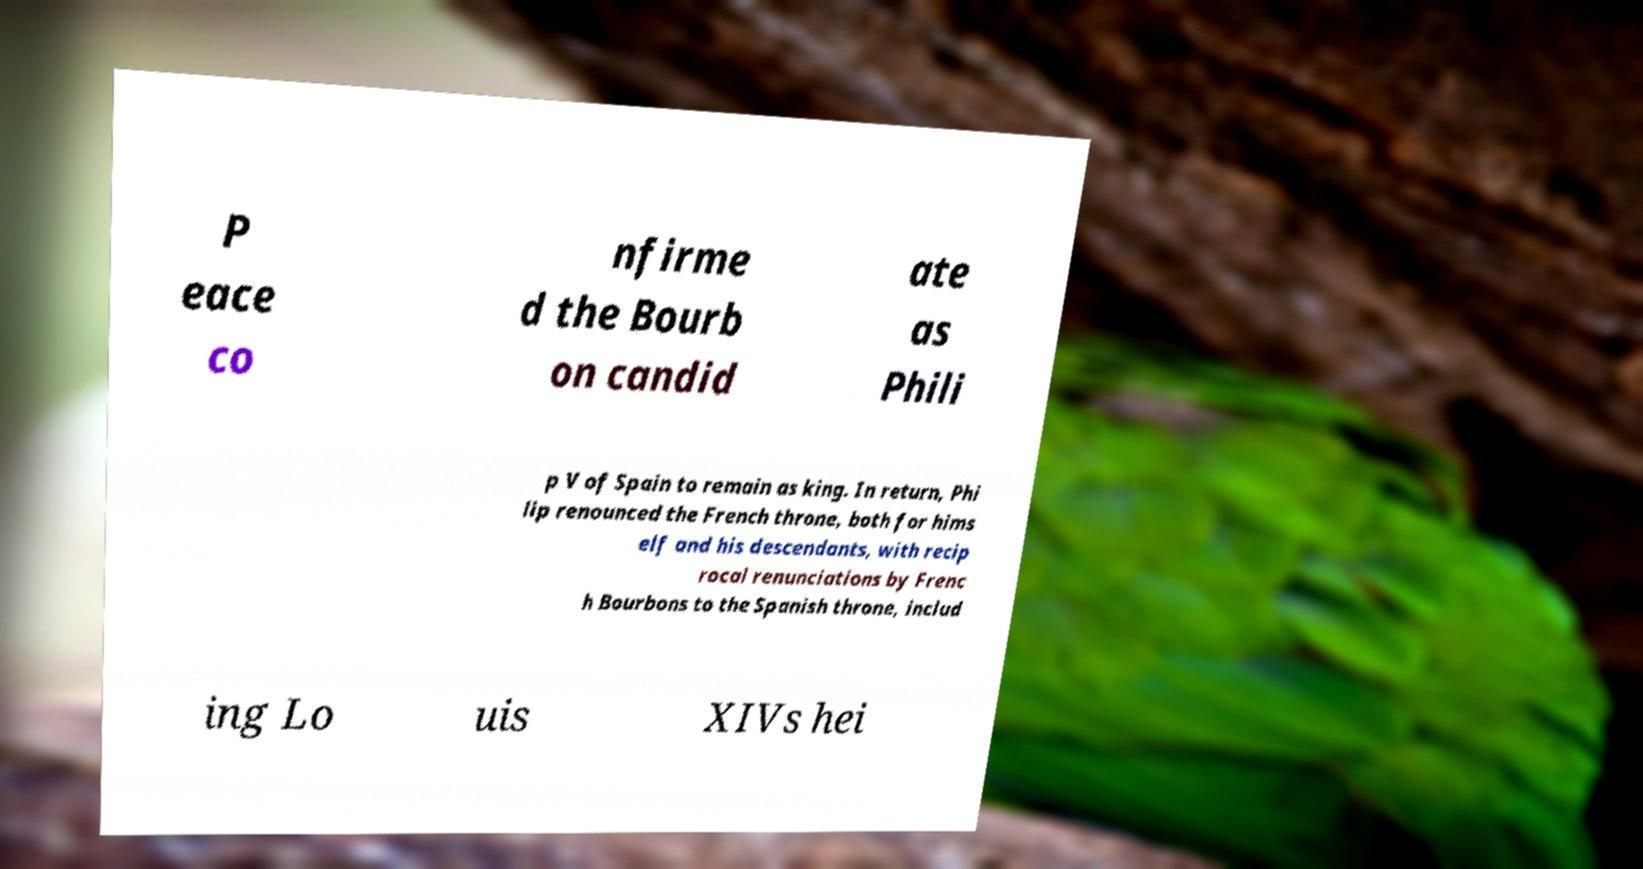Can you accurately transcribe the text from the provided image for me? P eace co nfirme d the Bourb on candid ate as Phili p V of Spain to remain as king. In return, Phi lip renounced the French throne, both for hims elf and his descendants, with recip rocal renunciations by Frenc h Bourbons to the Spanish throne, includ ing Lo uis XIVs hei 